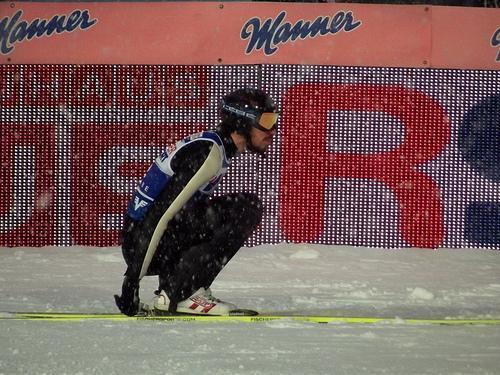How many people are pictured?
Give a very brief answer. 1. 